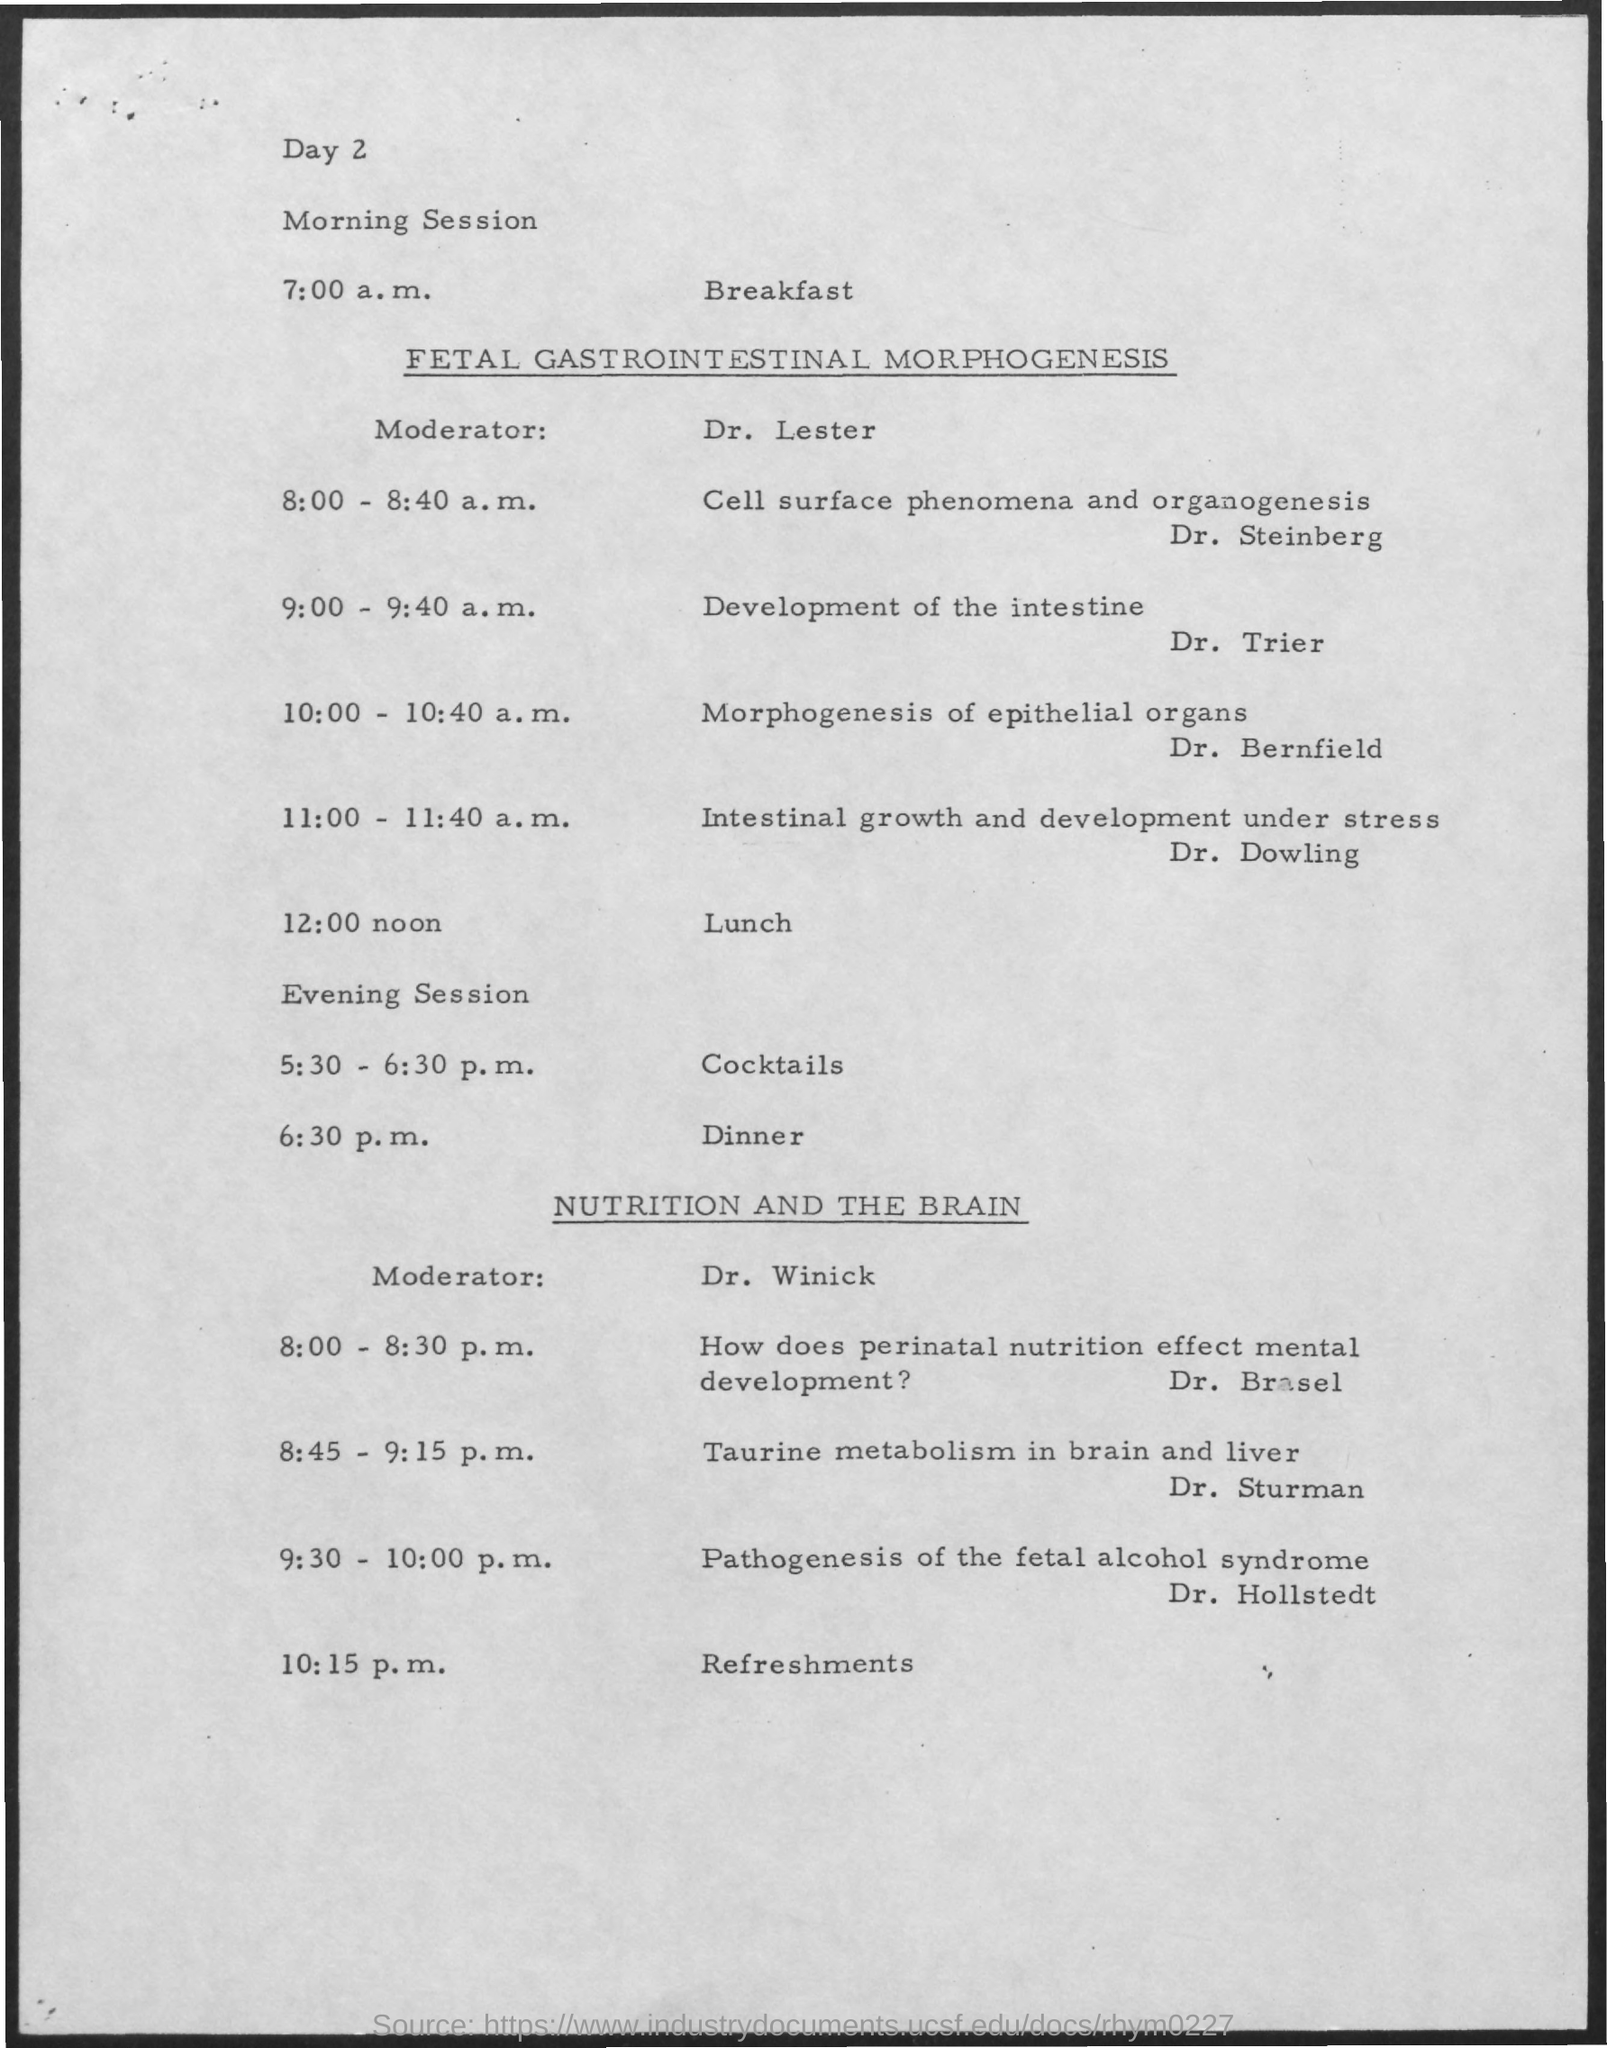Indicate a few pertinent items in this graphic. Dr. Trier's topic of interest is the development of the intestine. It is Dr. Hollstedt who will be the last speaker of the day. At 8:45-9:15 p.m., the topic of discussion was on Taurine metabolism in the brain and liver. The morning session is being moderated by Dr. Lester. The morning session will focus on the topic of fetal gastrointestinal morphogenesis. 